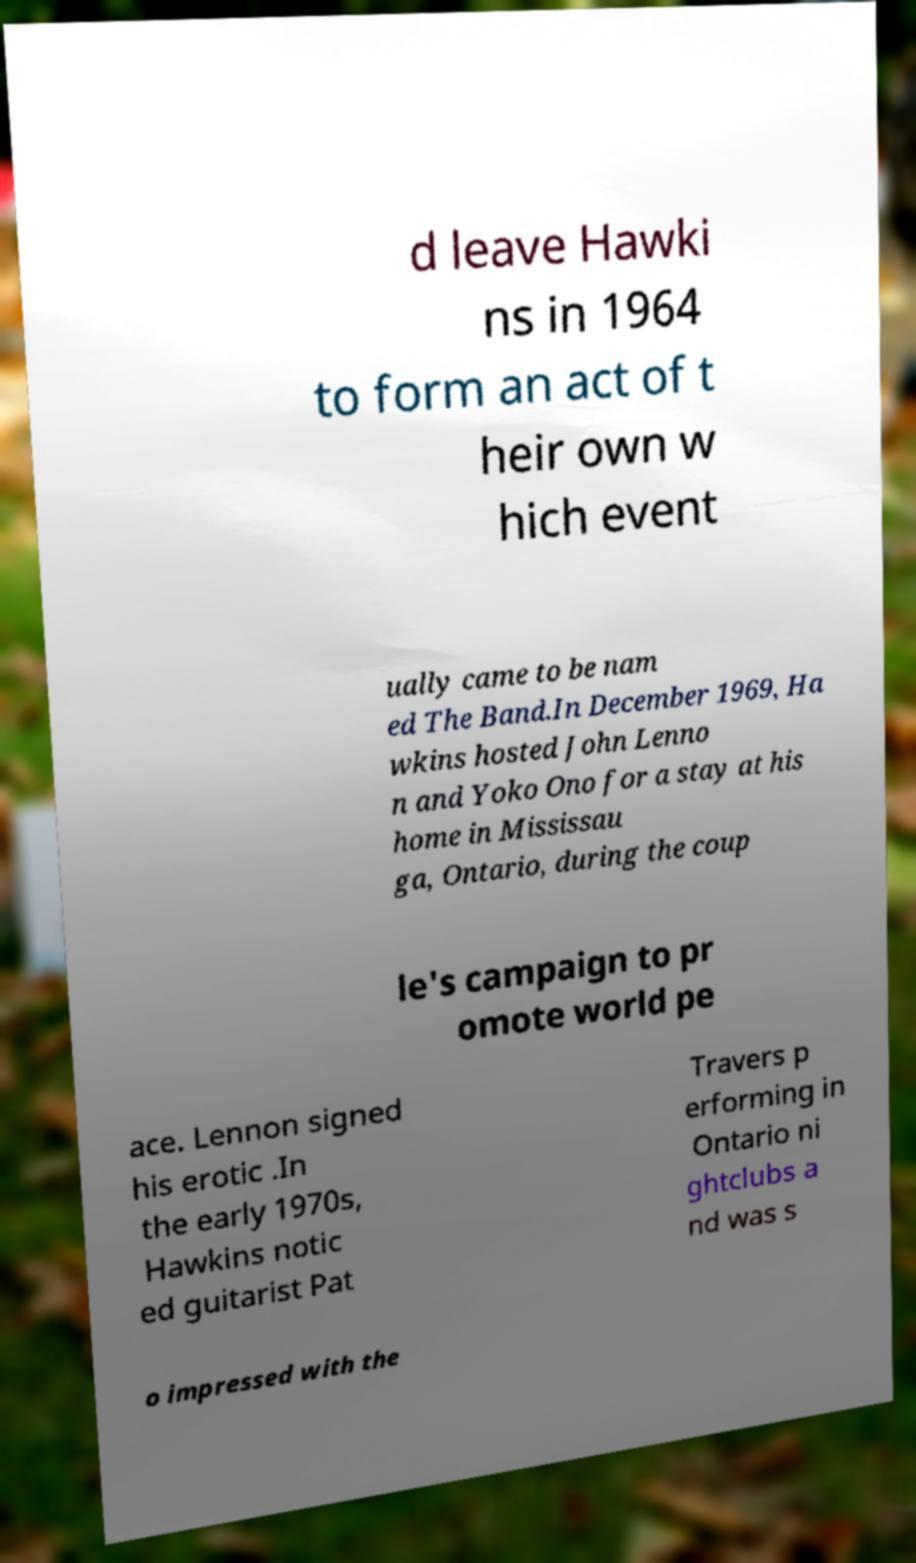For documentation purposes, I need the text within this image transcribed. Could you provide that? d leave Hawki ns in 1964 to form an act of t heir own w hich event ually came to be nam ed The Band.In December 1969, Ha wkins hosted John Lenno n and Yoko Ono for a stay at his home in Mississau ga, Ontario, during the coup le's campaign to pr omote world pe ace. Lennon signed his erotic .In the early 1970s, Hawkins notic ed guitarist Pat Travers p erforming in Ontario ni ghtclubs a nd was s o impressed with the 